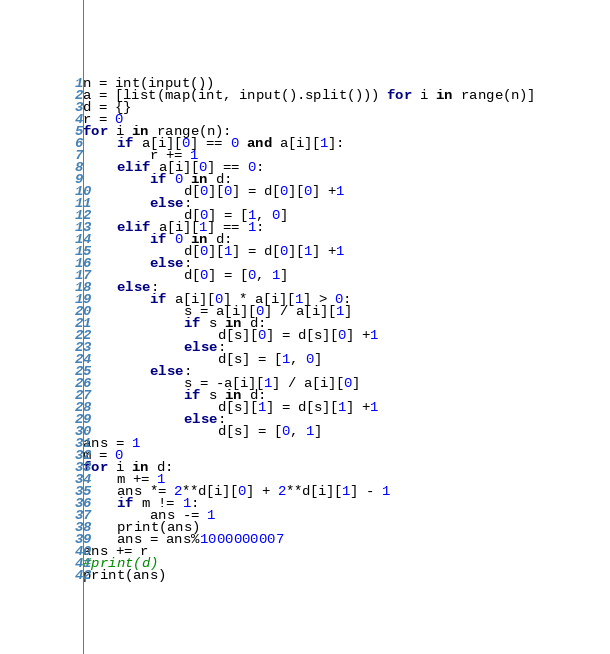Convert code to text. <code><loc_0><loc_0><loc_500><loc_500><_Python_>n = int(input())
a = [list(map(int, input().split())) for i in range(n)]
d = {}
r = 0
for i in range(n):
    if a[i][0] == 0 and a[i][1]:
        r += 1
    elif a[i][0] == 0:
        if 0 in d:
            d[0][0] = d[0][0] +1
        else:
            d[0] = [1, 0]
    elif a[i][1] == 1:
        if 0 in d:
            d[0][1] = d[0][1] +1
        else:
            d[0] = [0, 1]
    else:
        if a[i][0] * a[i][1] > 0:
            s = a[i][0] / a[i][1]
            if s in d:
                d[s][0] = d[s][0] +1
            else:
                d[s] = [1, 0]
        else:
            s = -a[i][1] / a[i][0]
            if s in d:
                d[s][1] = d[s][1] +1
            else:
                d[s] = [0, 1]
ans = 1
m = 0
for i in d:
    m += 1
    ans *= 2**d[i][0] + 2**d[i][1] - 1
    if m != 1:
        ans -= 1
    print(ans)
    ans = ans%1000000007
ans += r
#print(d)
print(ans)</code> 